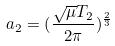<formula> <loc_0><loc_0><loc_500><loc_500>a _ { 2 } = ( \frac { \sqrt { \mu } T _ { 2 } } { 2 \pi } ) ^ { \frac { 2 } { 3 } }</formula> 